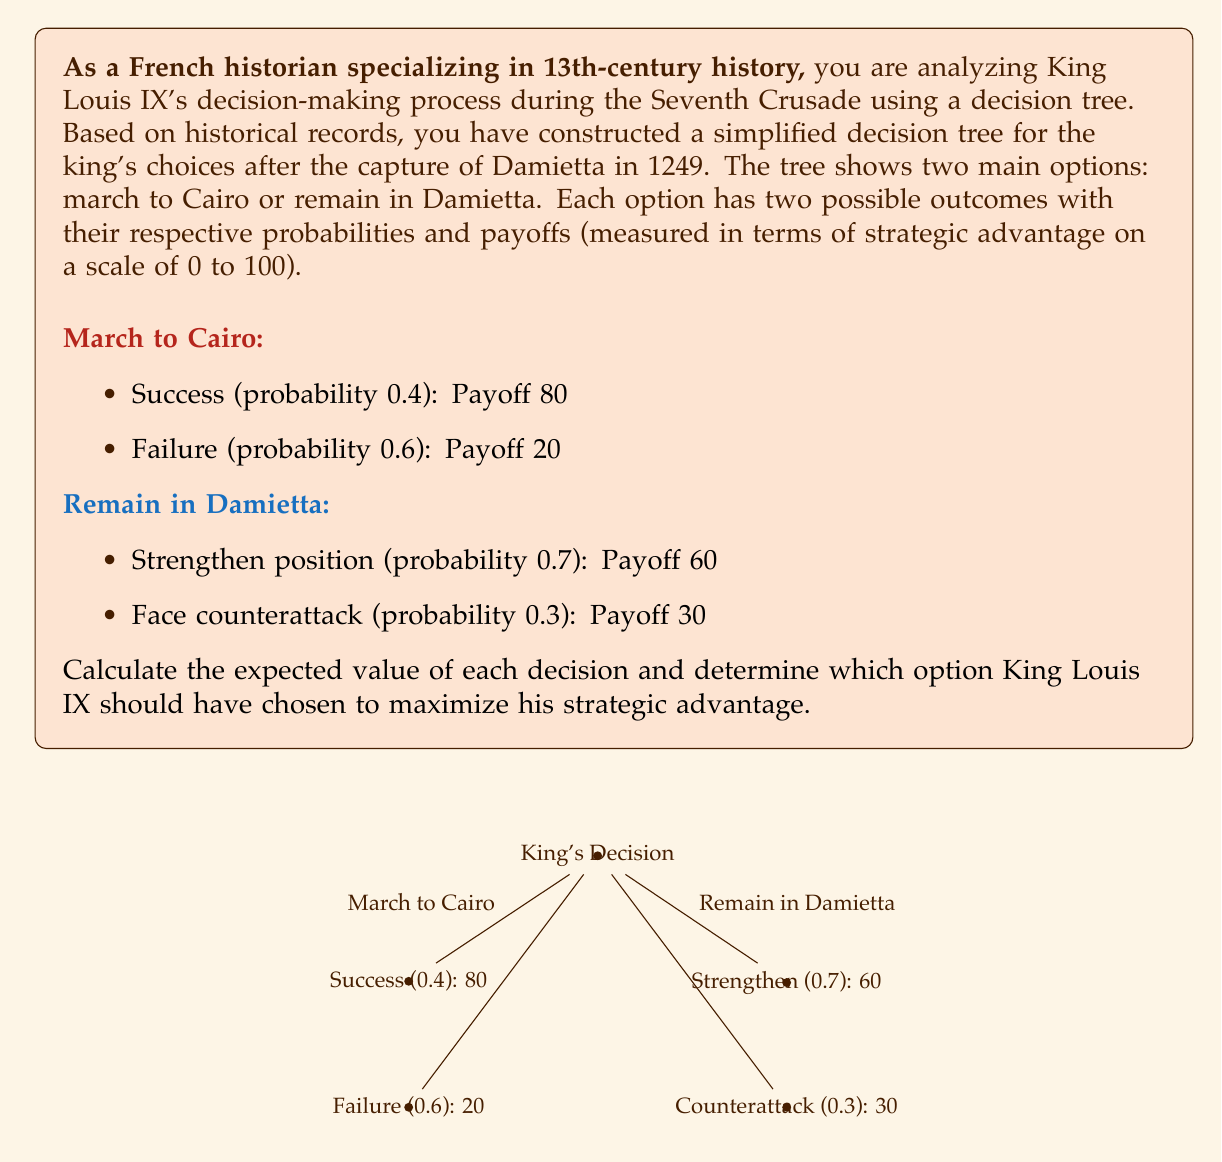Can you answer this question? To solve this problem, we need to calculate the expected value of each decision using the given probabilities and payoffs. The expected value is the sum of each outcome's probability multiplied by its payoff.

1. Calculate the expected value of marching to Cairo:
   $$E(\text{March to Cairo}) = (0.4 \times 80) + (0.6 \times 20)$$
   $$E(\text{March to Cairo}) = 32 + 12 = 44$$

2. Calculate the expected value of remaining in Damietta:
   $$E(\text{Remain in Damietta}) = (0.7 \times 60) + (0.3 \times 30)$$
   $$E(\text{Remain in Damietta}) = 42 + 9 = 51$$

3. Compare the expected values:
   The expected value of remaining in Damietta (51) is higher than the expected value of marching to Cairo (44).

Therefore, based on this simplified decision tree and the principle of maximizing expected value, King Louis IX should have chosen to remain in Damietta to maximize his strategic advantage.

It's important to note that this analysis is based on a simplified model and doesn't account for all the complex factors that would have influenced the king's decision in reality. As a historian, you would need to consider additional historical context and sources to fully understand the decision-making process.
Answer: King Louis IX should have chosen to remain in Damietta, as it has a higher expected value of 51 compared to 44 for marching to Cairo. 